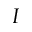Convert formula to latex. <formula><loc_0><loc_0><loc_500><loc_500>_ { I }</formula> 